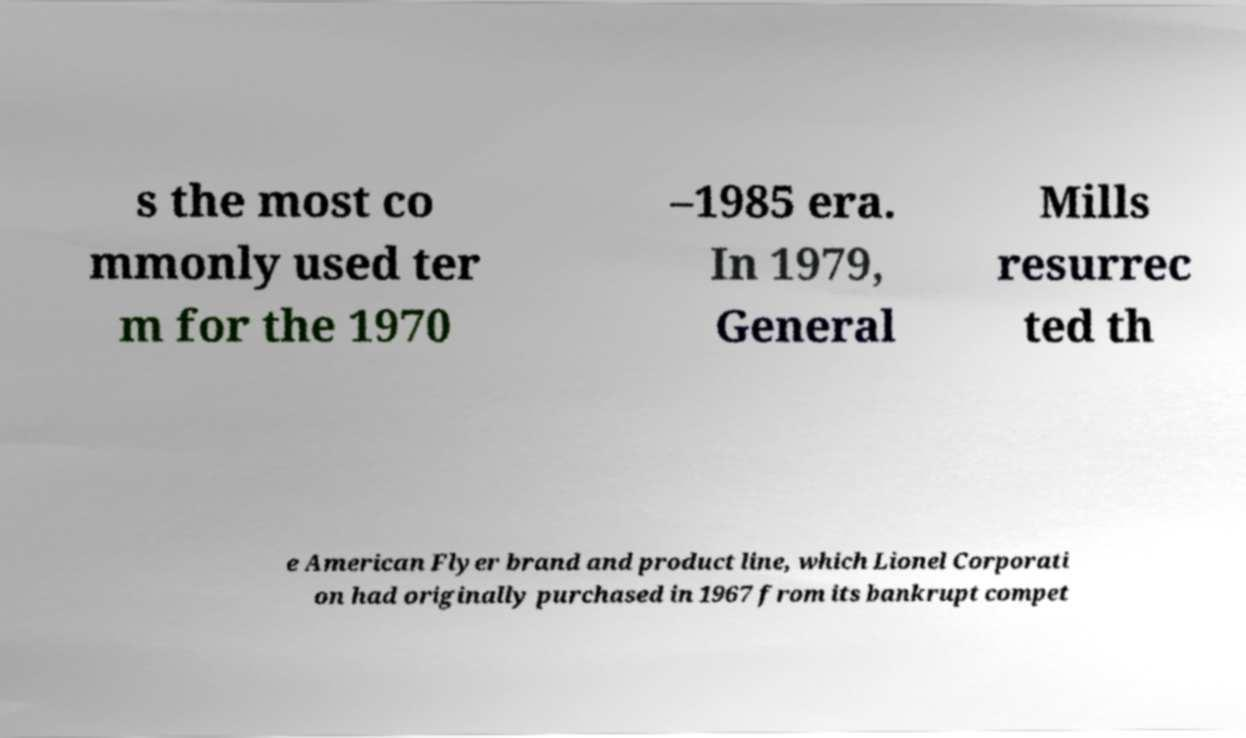There's text embedded in this image that I need extracted. Can you transcribe it verbatim? s the most co mmonly used ter m for the 1970 –1985 era. In 1979, General Mills resurrec ted th e American Flyer brand and product line, which Lionel Corporati on had originally purchased in 1967 from its bankrupt compet 